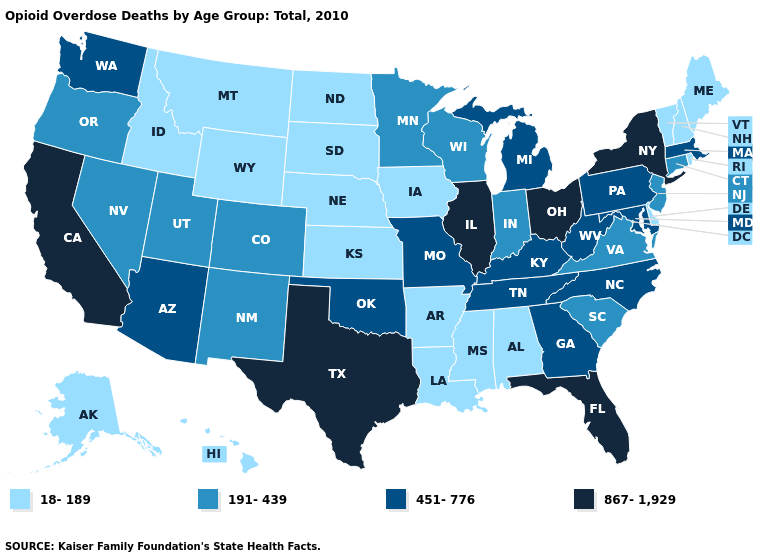Name the states that have a value in the range 867-1,929?
Quick response, please. California, Florida, Illinois, New York, Ohio, Texas. What is the value of Maryland?
Quick response, please. 451-776. Name the states that have a value in the range 191-439?
Answer briefly. Colorado, Connecticut, Indiana, Minnesota, Nevada, New Jersey, New Mexico, Oregon, South Carolina, Utah, Virginia, Wisconsin. What is the value of Delaware?
Short answer required. 18-189. Among the states that border South Carolina , which have the lowest value?
Answer briefly. Georgia, North Carolina. What is the highest value in states that border Iowa?
Be succinct. 867-1,929. What is the highest value in states that border South Dakota?
Write a very short answer. 191-439. Does Arizona have a higher value than Delaware?
Be succinct. Yes. What is the value of New Mexico?
Be succinct. 191-439. Name the states that have a value in the range 18-189?
Keep it brief. Alabama, Alaska, Arkansas, Delaware, Hawaii, Idaho, Iowa, Kansas, Louisiana, Maine, Mississippi, Montana, Nebraska, New Hampshire, North Dakota, Rhode Island, South Dakota, Vermont, Wyoming. Does the first symbol in the legend represent the smallest category?
Give a very brief answer. Yes. Among the states that border Indiana , which have the lowest value?
Short answer required. Kentucky, Michigan. Among the states that border Wyoming , which have the highest value?
Answer briefly. Colorado, Utah. What is the value of Nevada?
Keep it brief. 191-439. Which states have the lowest value in the USA?
Concise answer only. Alabama, Alaska, Arkansas, Delaware, Hawaii, Idaho, Iowa, Kansas, Louisiana, Maine, Mississippi, Montana, Nebraska, New Hampshire, North Dakota, Rhode Island, South Dakota, Vermont, Wyoming. 